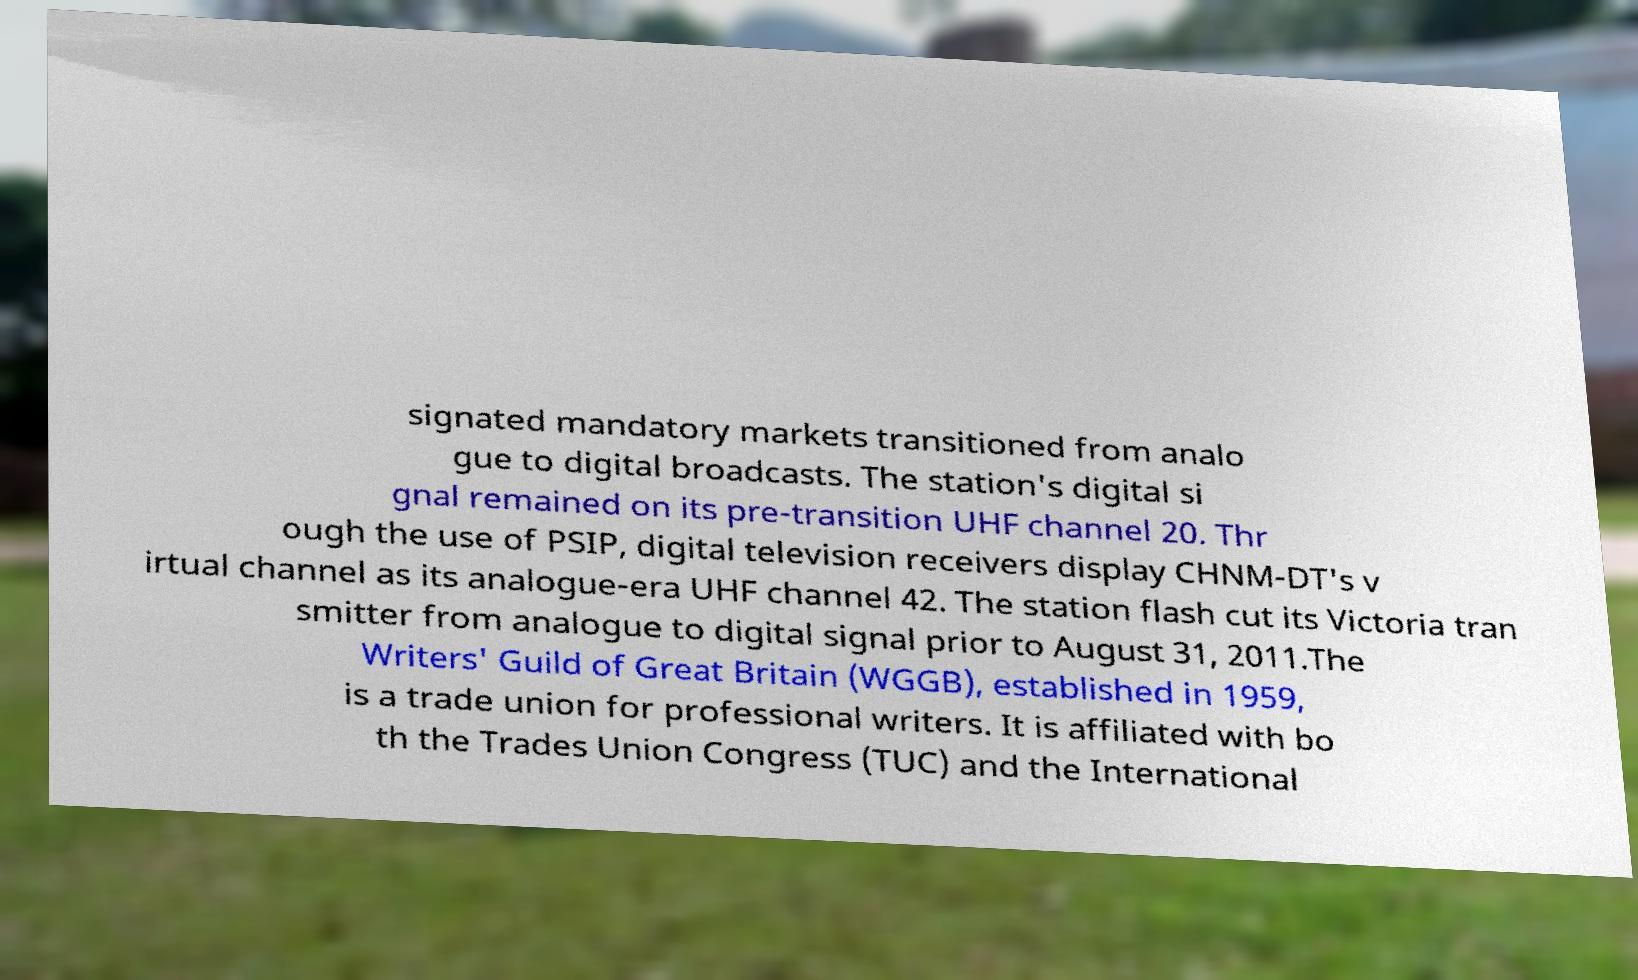For documentation purposes, I need the text within this image transcribed. Could you provide that? signated mandatory markets transitioned from analo gue to digital broadcasts. The station's digital si gnal remained on its pre-transition UHF channel 20. Thr ough the use of PSIP, digital television receivers display CHNM-DT's v irtual channel as its analogue-era UHF channel 42. The station flash cut its Victoria tran smitter from analogue to digital signal prior to August 31, 2011.The Writers' Guild of Great Britain (WGGB), established in 1959, is a trade union for professional writers. It is affiliated with bo th the Trades Union Congress (TUC) and the International 